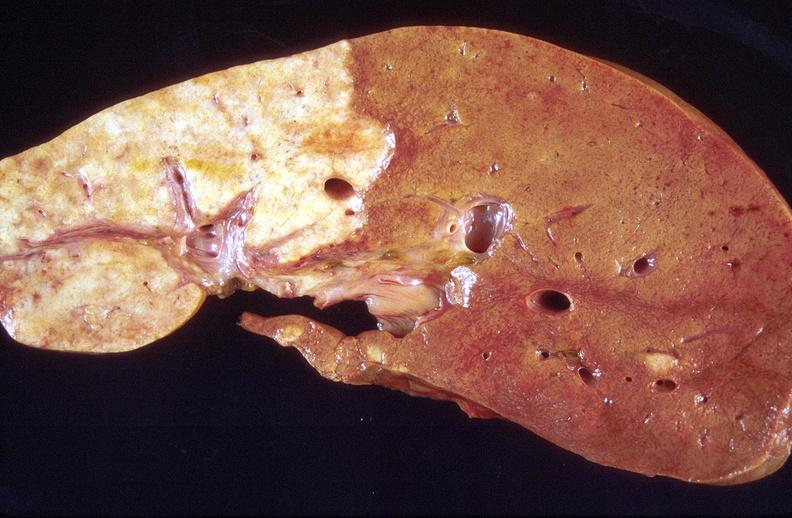does this image show cholangiocarcinoma?
Answer the question using a single word or phrase. Yes 